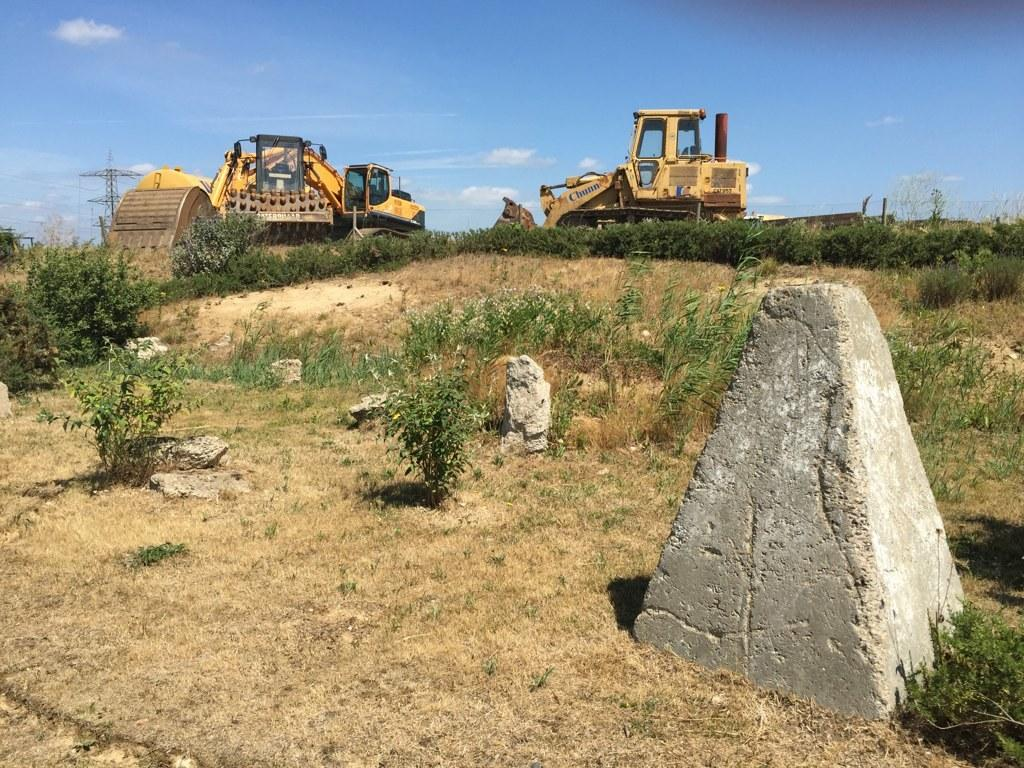What type of machinery can be seen on the land in the image? There are bulldozers on the land in the image. What else can be found on the land besides the bulldozers? The land has plants and rocks. What structure is located on the left side of the image? There is a tower on the left side of the image. What is visible at the top of the image? The sky is visible at the top of the image. What type of badge is being worn by the rocks in the image? There are no badges present in the image, as it features bulldozers, plants, rocks, a tower, and the sky. What is the reaction of the plants to the presence of the bulldozers in the image? The image does not depict a reaction from the plants, as it is a still image. 